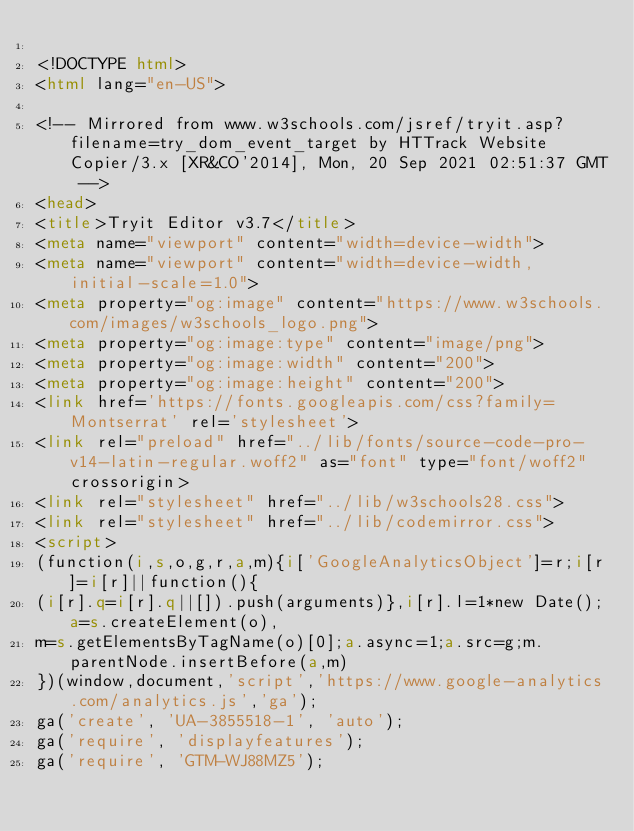Convert code to text. <code><loc_0><loc_0><loc_500><loc_500><_HTML_>
<!DOCTYPE html>
<html lang="en-US">

<!-- Mirrored from www.w3schools.com/jsref/tryit.asp?filename=try_dom_event_target by HTTrack Website Copier/3.x [XR&CO'2014], Mon, 20 Sep 2021 02:51:37 GMT -->
<head>
<title>Tryit Editor v3.7</title>
<meta name="viewport" content="width=device-width">
<meta name="viewport" content="width=device-width, initial-scale=1.0">
<meta property="og:image" content="https://www.w3schools.com/images/w3schools_logo.png">
<meta property="og:image:type" content="image/png">
<meta property="og:image:width" content="200">
<meta property="og:image:height" content="200">
<link href='https://fonts.googleapis.com/css?family=Montserrat' rel='stylesheet'>
<link rel="preload" href="../lib/fonts/source-code-pro-v14-latin-regular.woff2" as="font" type="font/woff2" crossorigin>
<link rel="stylesheet" href="../lib/w3schools28.css">
<link rel="stylesheet" href="../lib/codemirror.css">
<script>
(function(i,s,o,g,r,a,m){i['GoogleAnalyticsObject']=r;i[r]=i[r]||function(){
(i[r].q=i[r].q||[]).push(arguments)},i[r].l=1*new Date();a=s.createElement(o),
m=s.getElementsByTagName(o)[0];a.async=1;a.src=g;m.parentNode.insertBefore(a,m)
})(window,document,'script','https://www.google-analytics.com/analytics.js','ga');
ga('create', 'UA-3855518-1', 'auto');
ga('require', 'displayfeatures');
ga('require', 'GTM-WJ88MZ5');</code> 